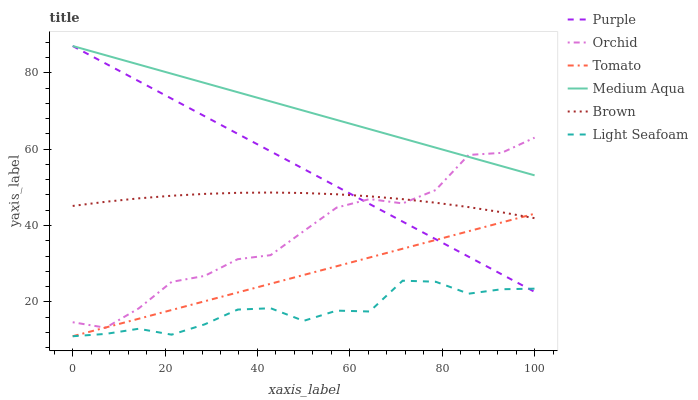Does Light Seafoam have the minimum area under the curve?
Answer yes or no. Yes. Does Medium Aqua have the maximum area under the curve?
Answer yes or no. Yes. Does Brown have the minimum area under the curve?
Answer yes or no. No. Does Brown have the maximum area under the curve?
Answer yes or no. No. Is Tomato the smoothest?
Answer yes or no. Yes. Is Orchid the roughest?
Answer yes or no. Yes. Is Brown the smoothest?
Answer yes or no. No. Is Brown the roughest?
Answer yes or no. No. Does Tomato have the lowest value?
Answer yes or no. Yes. Does Brown have the lowest value?
Answer yes or no. No. Does Medium Aqua have the highest value?
Answer yes or no. Yes. Does Brown have the highest value?
Answer yes or no. No. Is Light Seafoam less than Medium Aqua?
Answer yes or no. Yes. Is Medium Aqua greater than Tomato?
Answer yes or no. Yes. Does Tomato intersect Orchid?
Answer yes or no. Yes. Is Tomato less than Orchid?
Answer yes or no. No. Is Tomato greater than Orchid?
Answer yes or no. No. Does Light Seafoam intersect Medium Aqua?
Answer yes or no. No. 